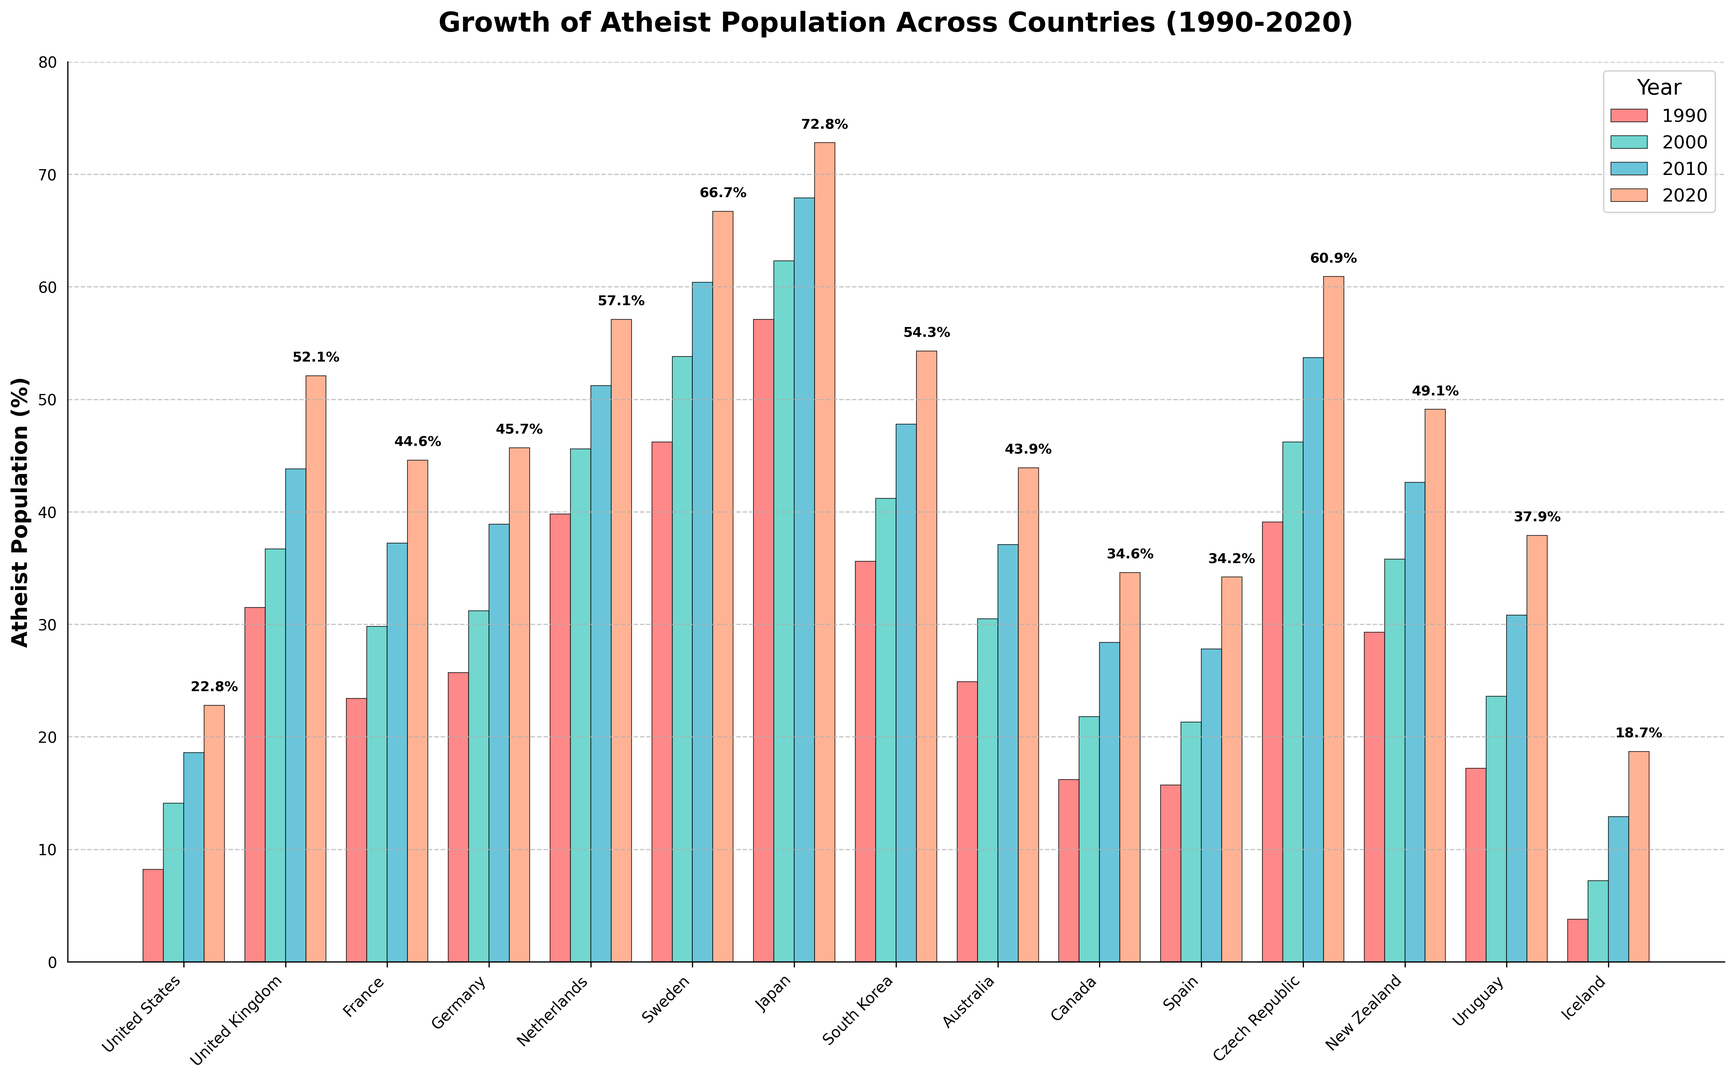Which country had the largest increase in the atheist population from 1990 to 2020? Calculate the difference for each country between 2020 and 1990, then identify the country with the largest increase. For instance, Japan went from 57.1% in 1990 to 72.8% in 2020, an increase of 15.7 percentage points, which is the largest.
Answer: Japan Which two decades saw the greatest growth in the atheist population for Sweden? Look at the data for Sweden across the four decades and calculate the growth for each: 1990-2000 (53.8-46.2=7.6), 2000-2010 (60.4-53.8=6.6), and 2010-2020 (66.7-60.4=6.3). The greatest growths are in the decade 1990-2000.
Answer: 1990-2000 In which year did the atheist population in Germany exceed 40% for the first time? Reviewing Germany's values: 1990 (25.7), 2000 (31.2), 2010 (38.9), 2020 (45.7). The population exceeded 40% in 2020.
Answer: 2020 What is the average atheist population in European countries in 2020? Calculate the average of France (44.6), Germany (45.7), United Kingdom (52.1), Netherlands (57.1), Sweden (66.7), Spain (34.2), and Czech Republic (60.9). Sum = 361.3 and the number of countries is 7, so 361.3/7.
Answer: 51.6% Which country had the smallest percentage of atheists in 1990? Reviewing the 1990 data, Iceland had the smallest percentage at 3.8%.
Answer: Iceland How does the atheist population growth in the USA compare to South Korea from 1990 to 2020? Calculate the growth for each: USA (22.8 - 8.2 = 14.6), South Korea (54.3 - 35.6 = 18.7). South Korea had greater growth.
Answer: South Korea had greater growth Visually, which country shows the most significant increase in bar height from 1990 to 2020? By comparing the bar heights for each country between 1990 and 2020 visually, Japan shows the most significant increase in bar height.
Answer: Japan Which countries had more than 50% atheist population by 2020? Identify countries with bars exceeding the 50% mark for the year 2020. These countries are Sweden, Netherlands, and Japan.
Answer: Sweden, Netherlands, Japan Which country had the highest atheist population in 2010? Checking the 2010 values, Japan had the highest with 67.9%.
Answer: Japan For which country did the atheist population double or more from 1990 to 2020? Calculate the ratio for each country (2020/1990). Iceland, for example, went from 3.8% to 18.7%, which more than quadrupled.
Answer: Iceland 